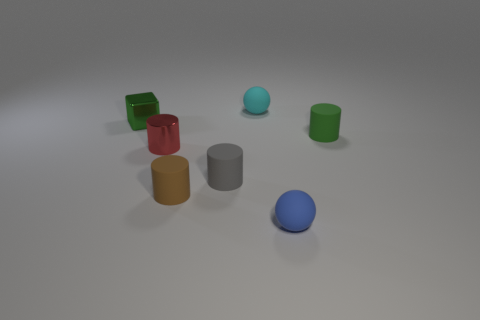What number of matte spheres have the same size as the red shiny thing?
Your response must be concise. 2. Is the small blue matte thing the same shape as the cyan object?
Your response must be concise. Yes. What is the color of the sphere in front of the small rubber cylinder that is to the right of the tiny blue thing?
Keep it short and to the point. Blue. How big is the thing that is left of the tiny brown matte thing and in front of the shiny cube?
Your response must be concise. Small. Is there anything else that is the same color as the metallic cylinder?
Provide a short and direct response. No. The red object that is the same material as the green cube is what shape?
Offer a terse response. Cylinder. There is a brown object; is it the same shape as the small green thing that is to the right of the small gray rubber cylinder?
Keep it short and to the point. Yes. There is a green object that is on the right side of the tiny matte ball that is behind the red metal thing; what is it made of?
Make the answer very short. Rubber. Is the number of tiny cyan balls that are in front of the small brown cylinder the same as the number of large blue shiny things?
Offer a very short reply. Yes. Is there anything else that is made of the same material as the gray object?
Your answer should be very brief. Yes. 